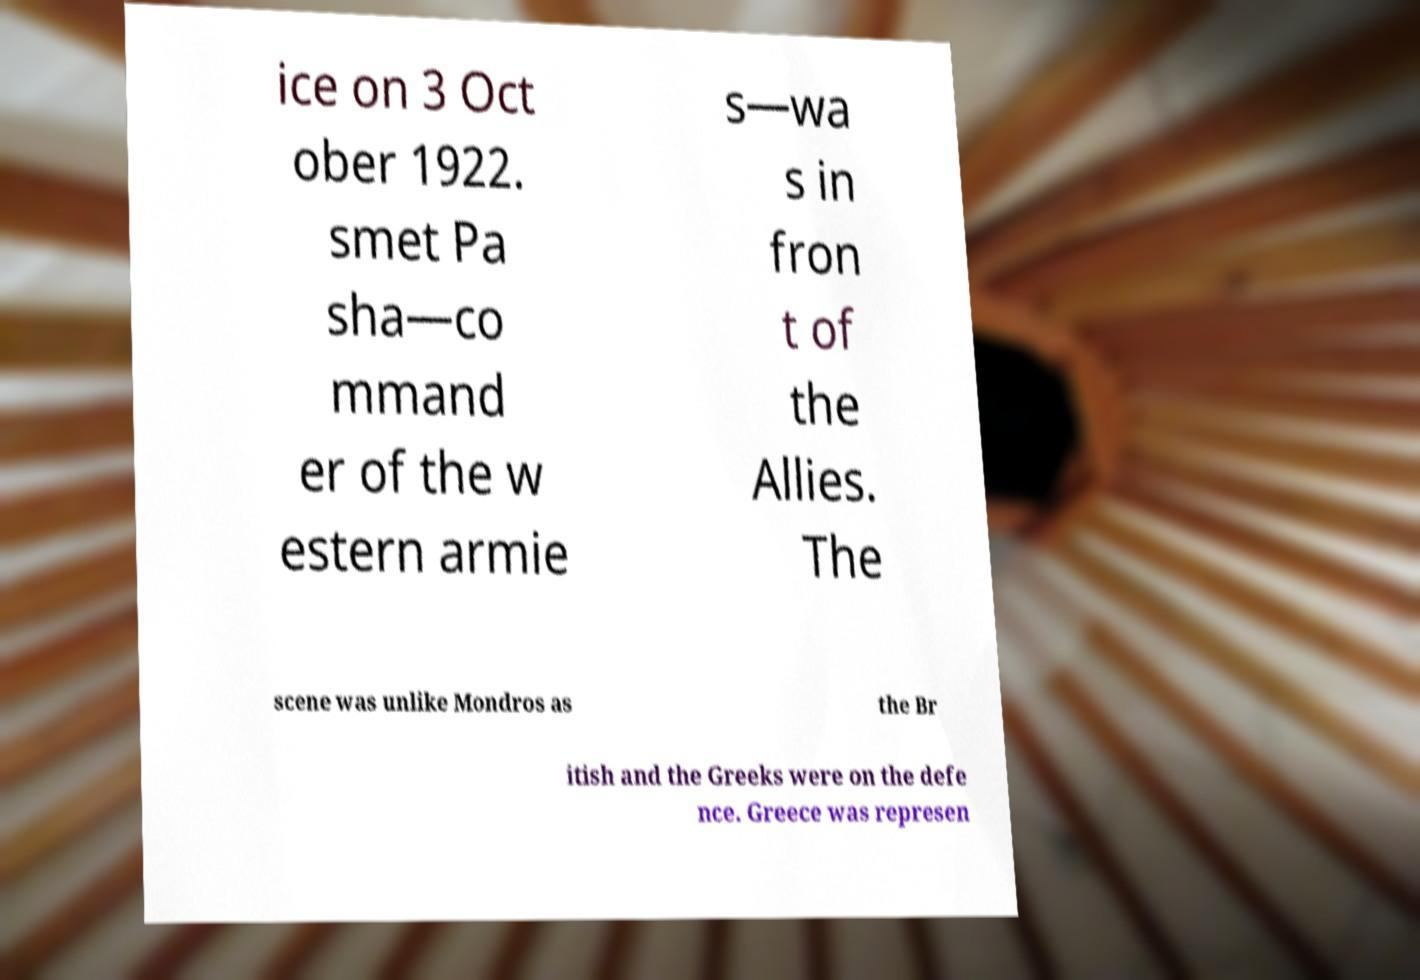Can you accurately transcribe the text from the provided image for me? ice on 3 Oct ober 1922. smet Pa sha—co mmand er of the w estern armie s—wa s in fron t of the Allies. The scene was unlike Mondros as the Br itish and the Greeks were on the defe nce. Greece was represen 